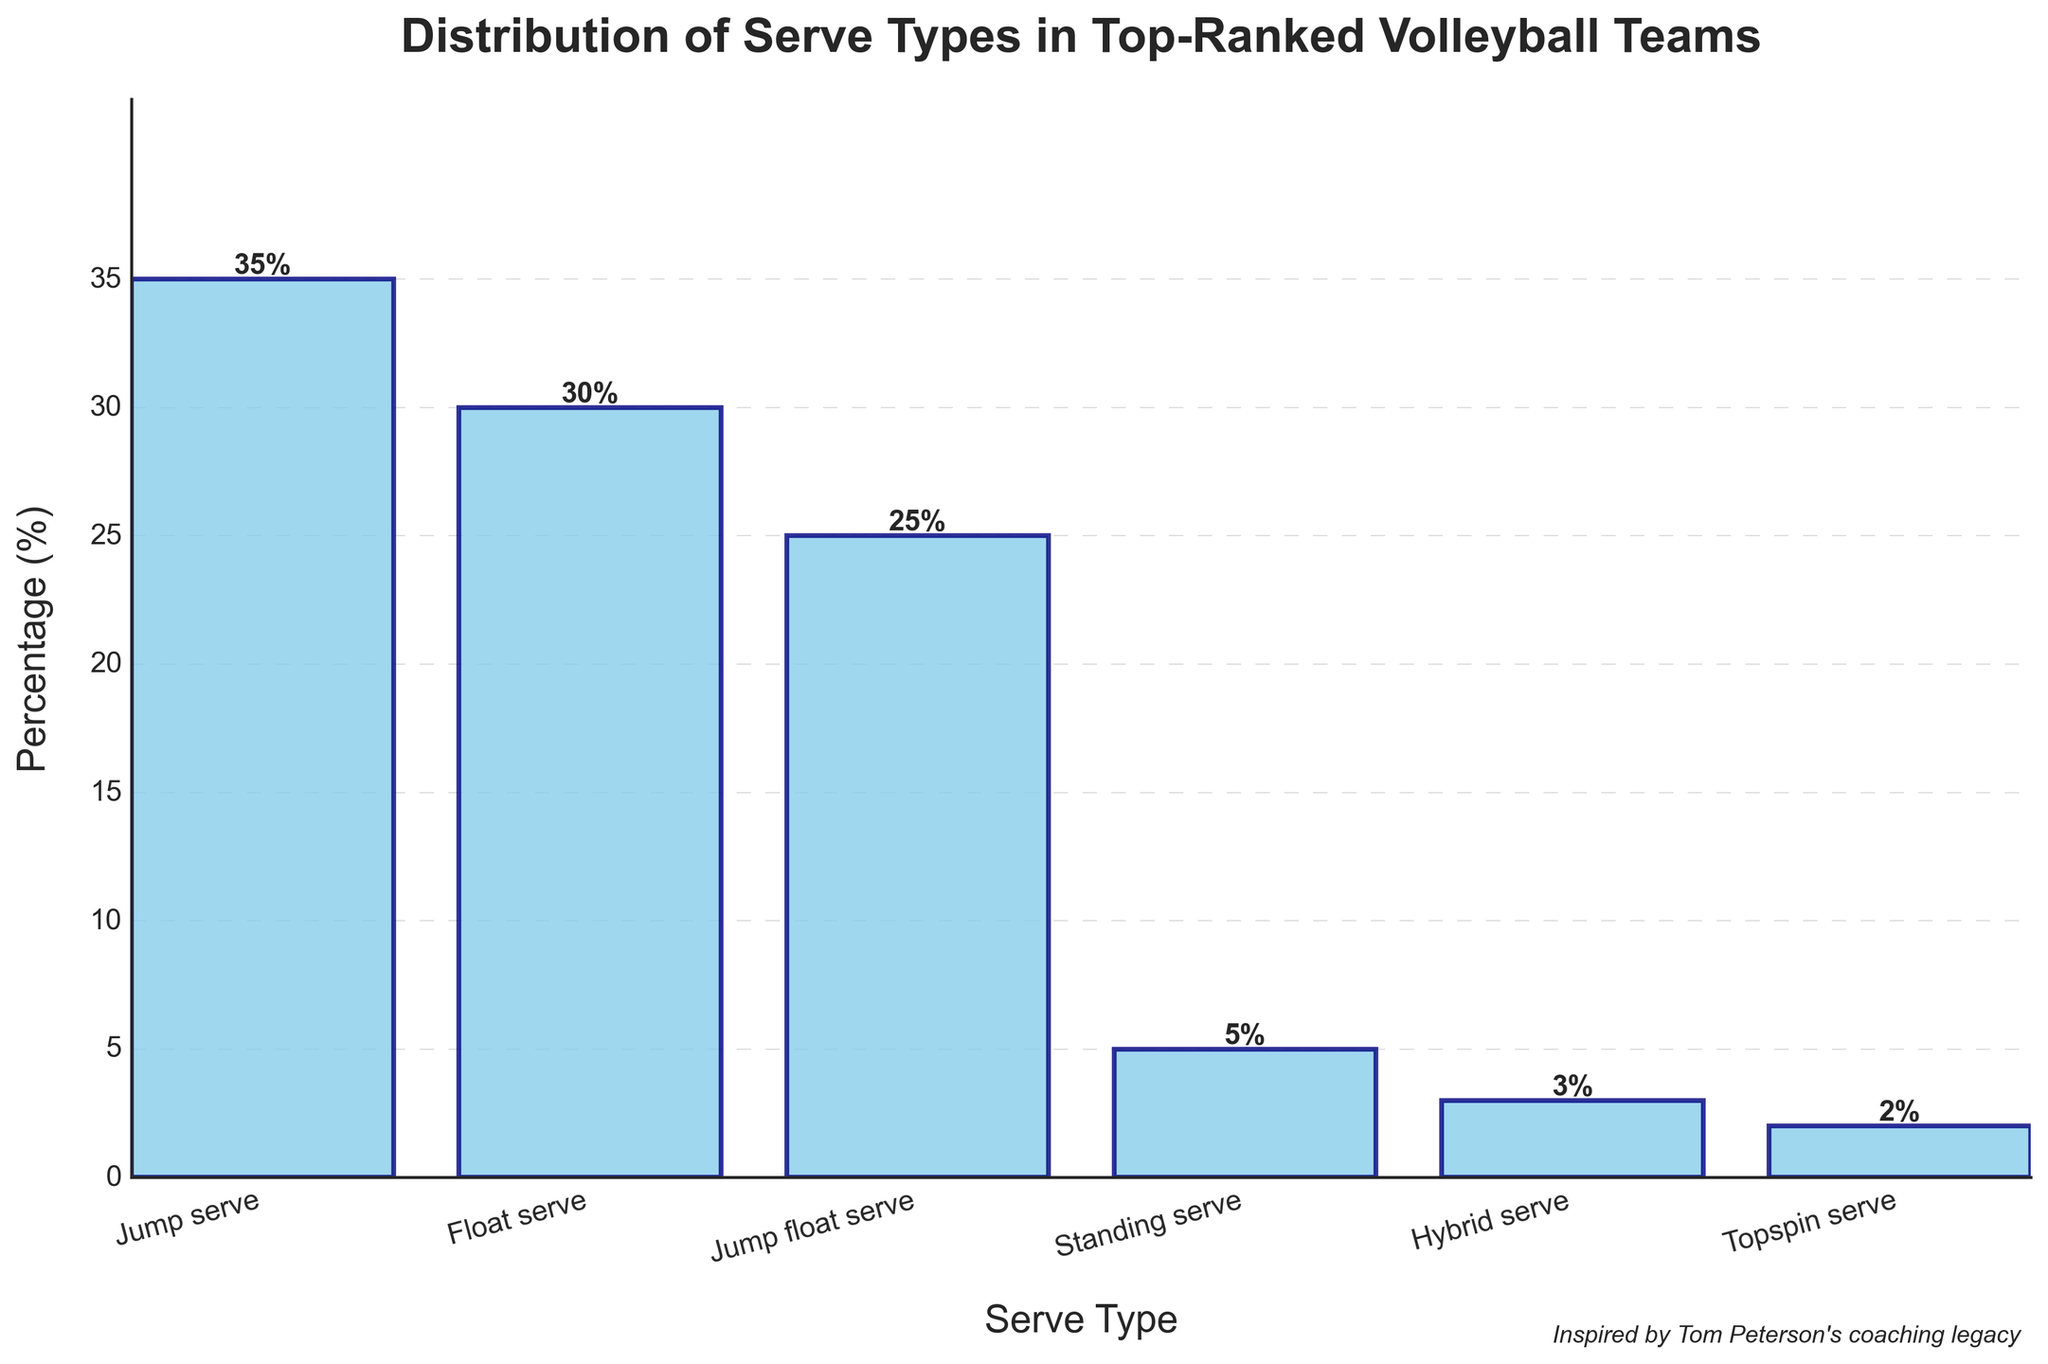What is the most common serve type used by top-ranked volleyball teams? The tallest bar represents the most common serve type used by top-ranked volleyball teams. The height of the "Jump serve" bar is the highest at 35%.
Answer: Jump serve What percentage of serves are hybrid serves? The bar labeled "Hybrid serve" shows the percentage of hybrid serves, which is 3%.
Answer: 3% How many percentage points higher is the usage of float serves compared to hybrid serves? To find the difference in percentages, subtract the percentage of hybrid serves (3%) from the float serves (30%). 30% - 3% = 27%.
Answer: 27% What is the combined usage percentage of jump float serves and standing serves? To find the combined percentage, add the percentages for "Jump float serve" (25%) and "Standing serve" (5%). 25% + 5% = 30%.
Answer: 30% Which serve type is used the least by top-ranked volleyball teams? Among the bars, the one with the smallest height represents the least used serve type. "Topspin serve" has the lowest percentage at 2%.
Answer: Topspin serve How does the usage of jump serves compare with float serves? The "Jump serve" bar height is 35%, and the "Float serve" bar height is 30%. 35% is greater than 30%, indicating that jump serves are used more than float serves.
Answer: Jump serves are used more Which serve type has a percentage just below jump float serve? The "Jump float serve" has a percentage of 25%. The next highest bar is "Float serve" at 30%, which is actually above it. Therefore, the answers should be below it, i.e., one just below is "Standing serve" at 5%.
Answer: Standing serve What is the average percentage of all the six serve types combined? Add the percentages of all serve types and divide by the number of serve types: (35% + 30% + 25% + 5% + 3% + 2%) / 6. The total is 100%. 100% / 6 = 16.67%.
Answer: 16.67% Which three serve types are used the most, and what is their combined percentage? The three tallest bars represent the most common serve types: "Jump serve" (35%), "Float serve" (30%), and "Jump float serve" (25%). Their combined percentage is 35% + 30% + 25% = 90%.
Answer: Jump serve, Float serve, and Jump float serve, 90% List the serve types in descending order of their usage percentage. Rank the serve types by their bar heights in descending order: Jump serve (35%), Float serve (30%), Jump float serve (25%), Standing serve (5%), Hybrid serve (3%), and Topspin serve (2%).
Answer: Jump serve, Float serve, Jump float serve, Standing serve, Hybrid serve, Topspin serve 